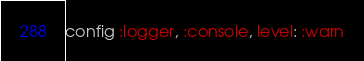Convert code to text. <code><loc_0><loc_0><loc_500><loc_500><_Elixir_>config :logger, :console, level: :warn
</code> 